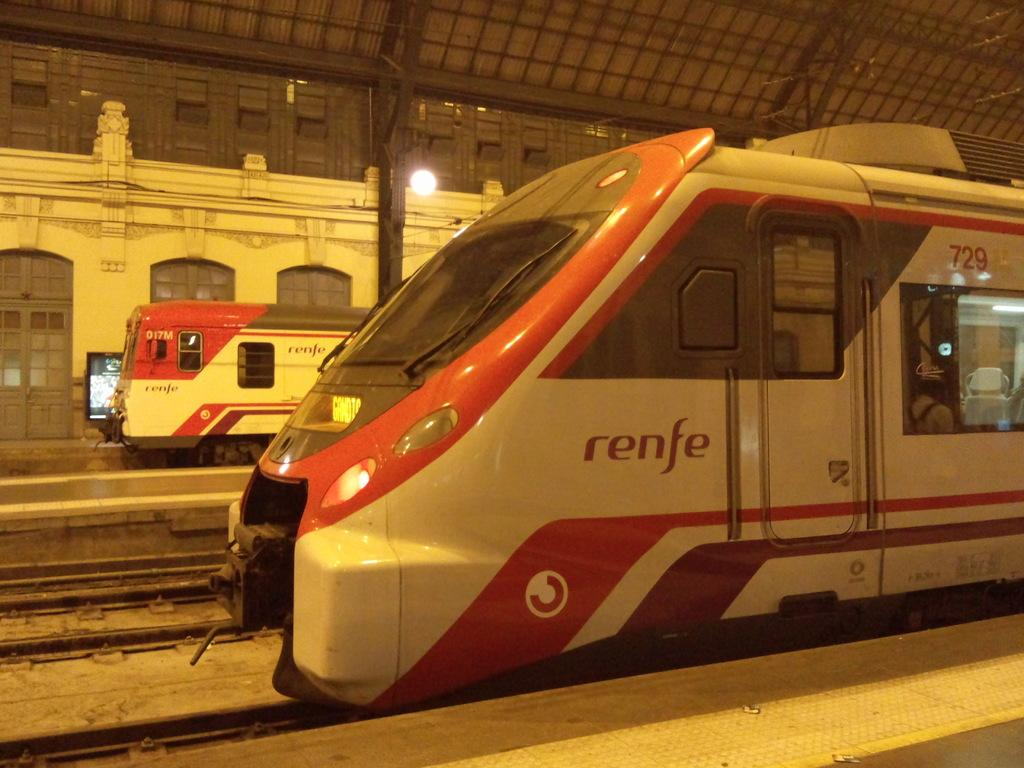How many trains can be seen in the image? There are two trains in the image. Where are the trains located? The trains are on railway tracks. What else can be seen in the image besides the trains? There are platforms, lights, a screen, and other items in the image. Can you tell me how many eyes are visible on the trains in the image? There are no eyes visible on the trains in the image, as trains do not have eyes. What type of toy can be seen playing with the screen in the image? There is no toy present in the image, and therefore no such activity can be observed. 